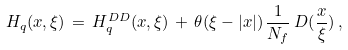Convert formula to latex. <formula><loc_0><loc_0><loc_500><loc_500>H _ { q } ( x , \xi ) \, = \, H _ { q } ^ { D D } ( x , \xi ) \, + \, \theta ( \xi - | x | ) \, \frac { 1 } { N _ { f } } \, D ( \frac { x } { \xi } ) \, ,</formula> 